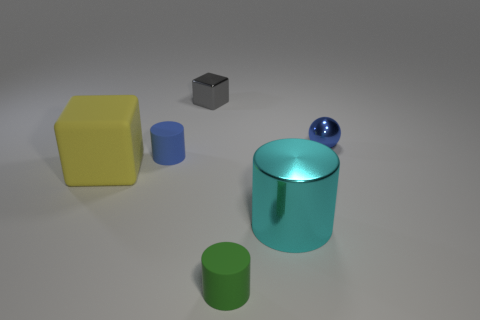Subtract all big cylinders. How many cylinders are left? 2 Subtract all gray blocks. How many blocks are left? 1 Subtract all cubes. How many objects are left? 4 Add 5 large blue shiny objects. How many large blue shiny objects exist? 5 Add 2 cyan cylinders. How many objects exist? 8 Subtract 0 gray cylinders. How many objects are left? 6 Subtract 3 cylinders. How many cylinders are left? 0 Subtract all purple cubes. Subtract all brown balls. How many cubes are left? 2 Subtract all purple spheres. How many purple cylinders are left? 0 Subtract all tiny yellow metallic balls. Subtract all tiny shiny cubes. How many objects are left? 5 